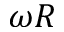Convert formula to latex. <formula><loc_0><loc_0><loc_500><loc_500>\omega R</formula> 